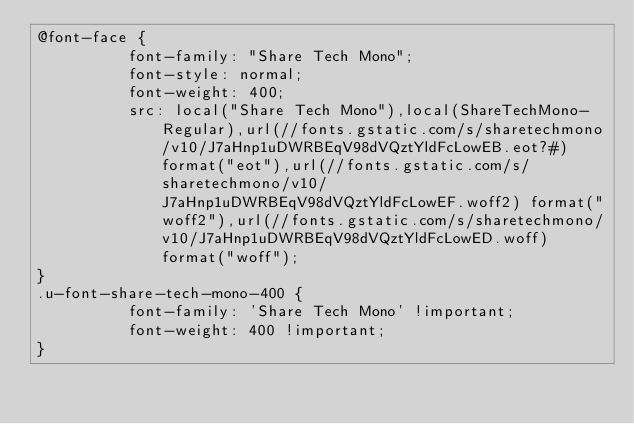Convert code to text. <code><loc_0><loc_0><loc_500><loc_500><_CSS_>@font-face {
          font-family: "Share Tech Mono";
          font-style: normal;
          font-weight: 400;
          src: local("Share Tech Mono"),local(ShareTechMono-Regular),url(//fonts.gstatic.com/s/sharetechmono/v10/J7aHnp1uDWRBEqV98dVQztYldFcLowEB.eot?#) format("eot"),url(//fonts.gstatic.com/s/sharetechmono/v10/J7aHnp1uDWRBEqV98dVQztYldFcLowEF.woff2) format("woff2"),url(//fonts.gstatic.com/s/sharetechmono/v10/J7aHnp1uDWRBEqV98dVQztYldFcLowED.woff) format("woff");
}
.u-font-share-tech-mono-400 {
          font-family: 'Share Tech Mono' !important;
          font-weight: 400 !important;
}</code> 